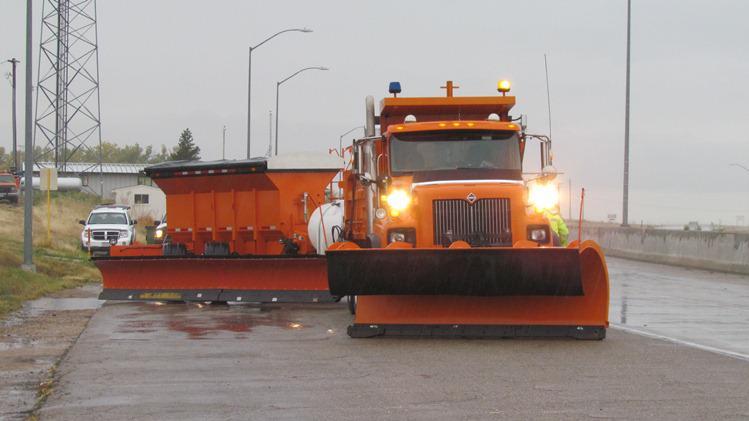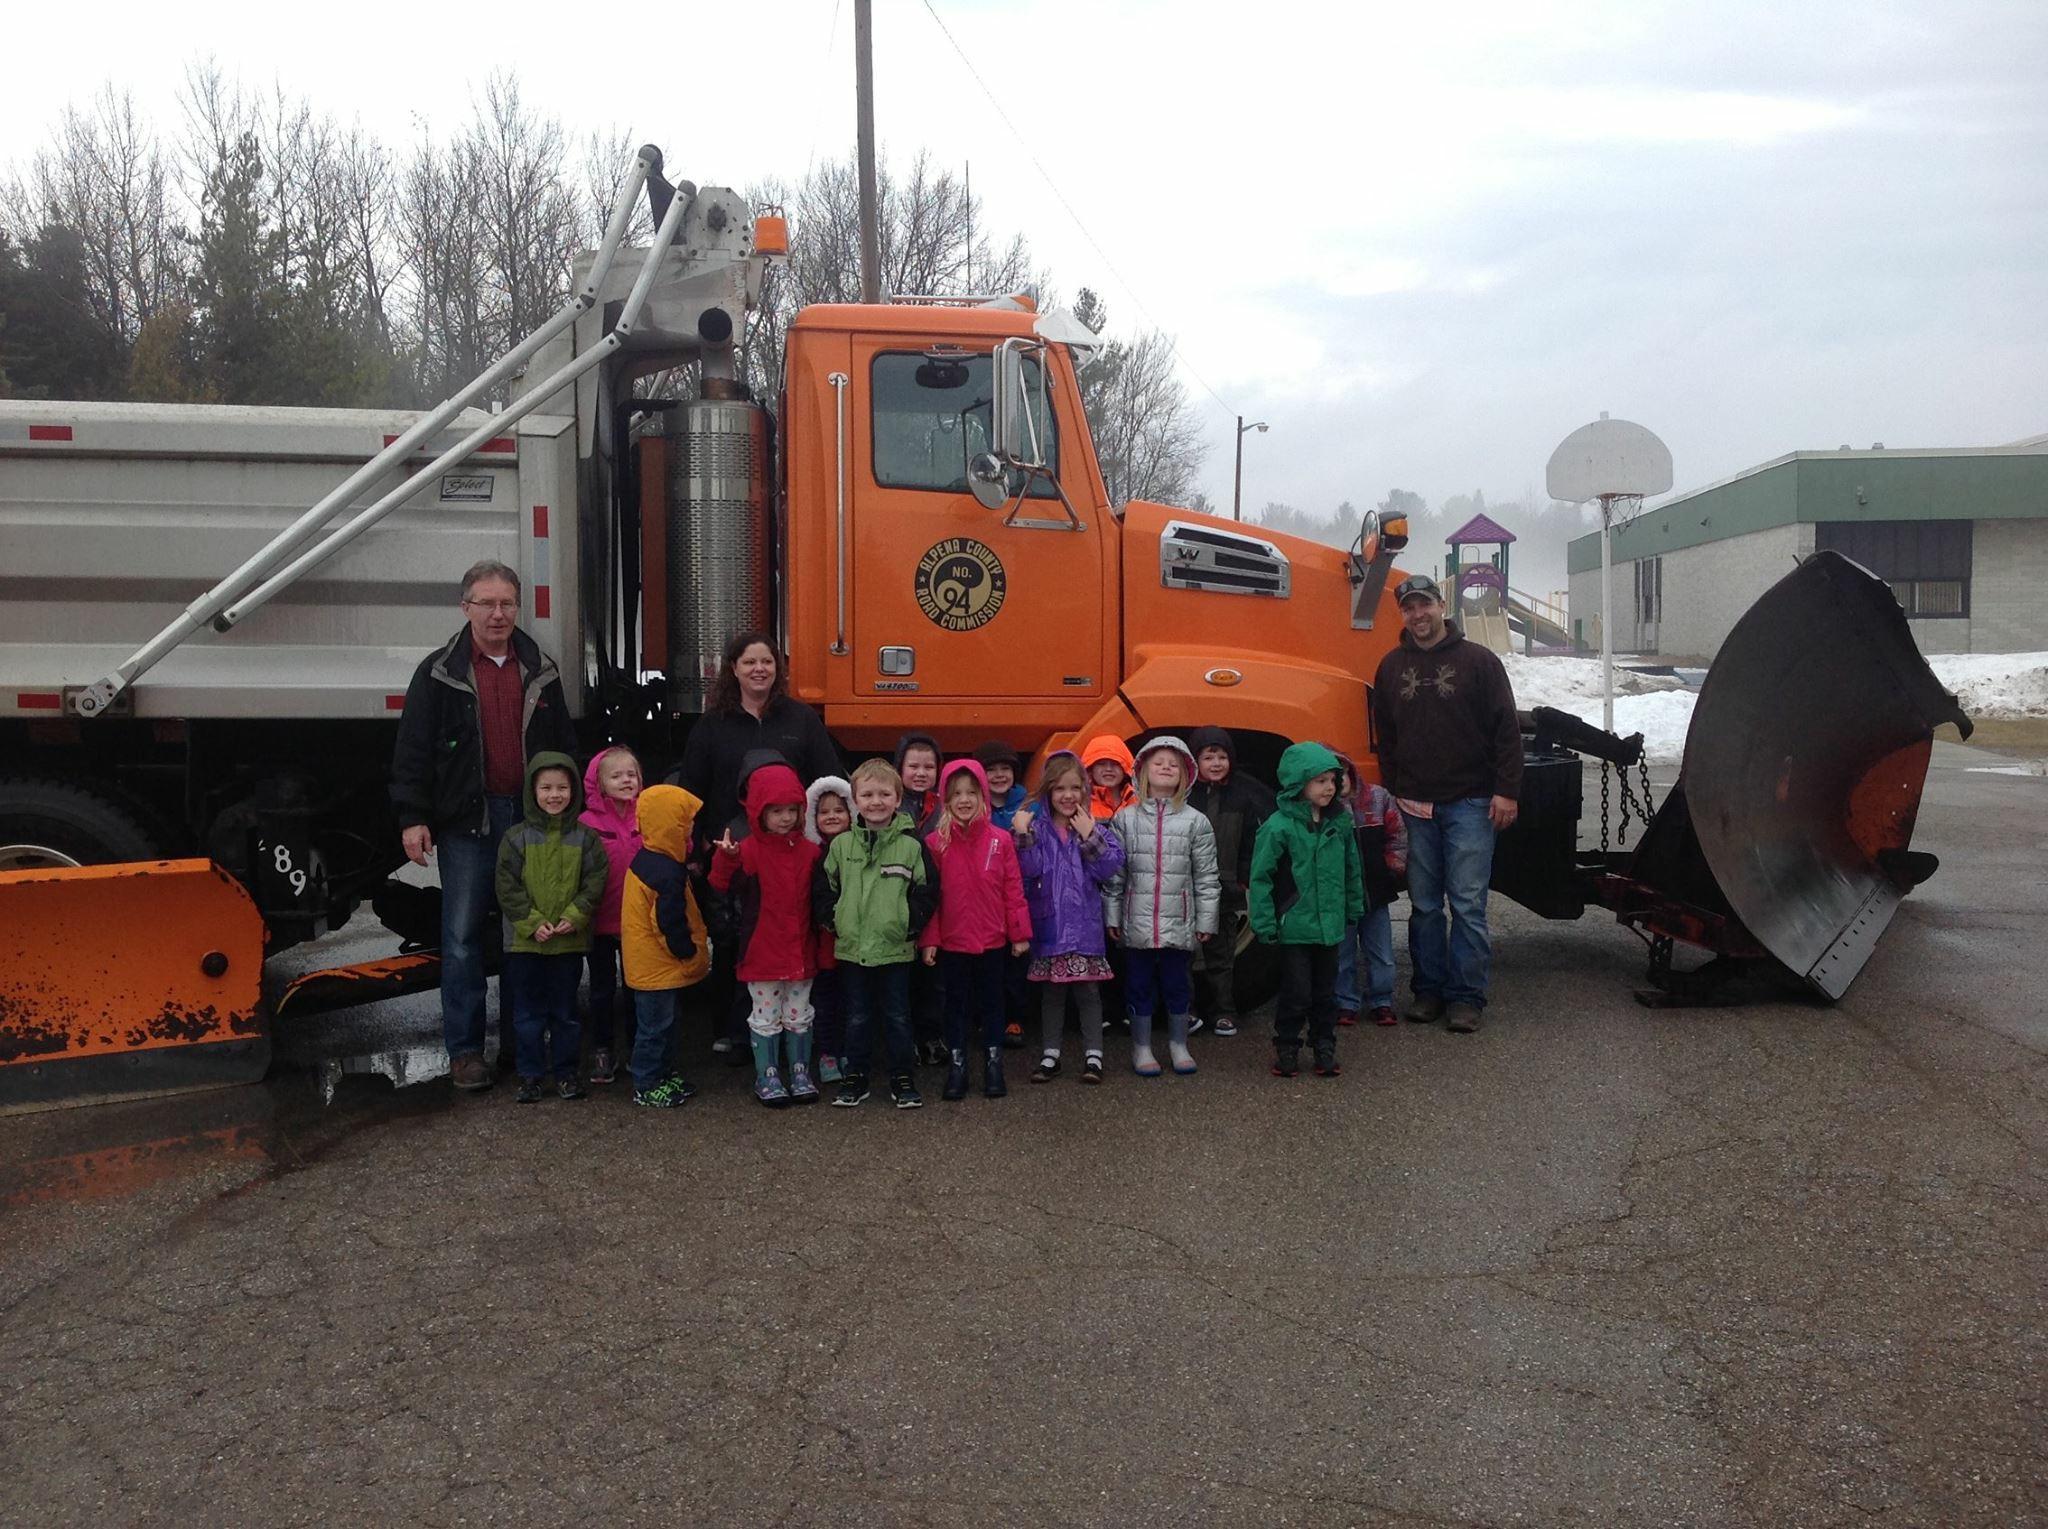The first image is the image on the left, the second image is the image on the right. Examine the images to the left and right. Is the description "Left image shows one orange truck in front of a yellower piece of equipment." accurate? Answer yes or no. No. 